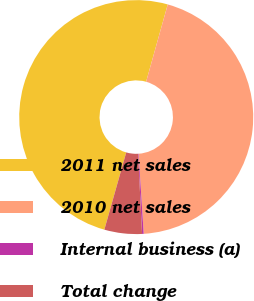<chart> <loc_0><loc_0><loc_500><loc_500><pie_chart><fcel>2011 net sales<fcel>2010 net sales<fcel>Internal business (a)<fcel>Total change<nl><fcel>49.95%<fcel>44.64%<fcel>0.22%<fcel>5.19%<nl></chart> 